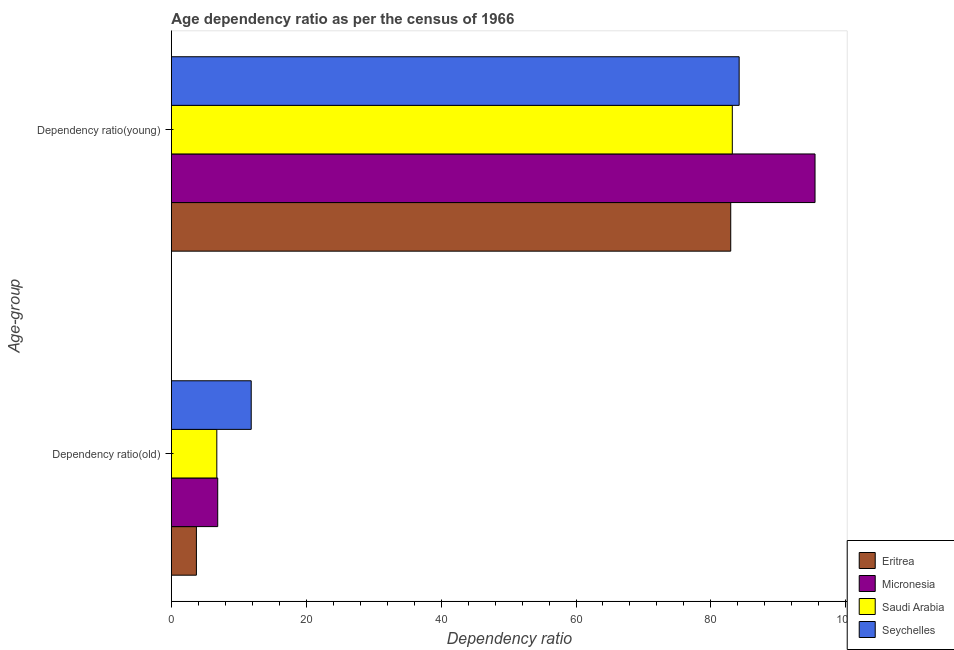How many groups of bars are there?
Make the answer very short. 2. Are the number of bars on each tick of the Y-axis equal?
Keep it short and to the point. Yes. How many bars are there on the 1st tick from the bottom?
Offer a very short reply. 4. What is the label of the 1st group of bars from the top?
Provide a succinct answer. Dependency ratio(young). What is the age dependency ratio(young) in Saudi Arabia?
Your response must be concise. 83.18. Across all countries, what is the maximum age dependency ratio(old)?
Provide a succinct answer. 11.84. Across all countries, what is the minimum age dependency ratio(young)?
Provide a short and direct response. 82.95. In which country was the age dependency ratio(old) maximum?
Keep it short and to the point. Seychelles. In which country was the age dependency ratio(young) minimum?
Make the answer very short. Eritrea. What is the total age dependency ratio(old) in the graph?
Make the answer very short. 29.16. What is the difference between the age dependency ratio(old) in Eritrea and that in Seychelles?
Offer a very short reply. -8.13. What is the difference between the age dependency ratio(old) in Eritrea and the age dependency ratio(young) in Seychelles?
Keep it short and to the point. -80.48. What is the average age dependency ratio(old) per country?
Provide a succinct answer. 7.29. What is the difference between the age dependency ratio(young) and age dependency ratio(old) in Micronesia?
Your answer should be compact. 88.57. What is the ratio of the age dependency ratio(old) in Micronesia to that in Eritrea?
Provide a succinct answer. 1.85. What does the 4th bar from the top in Dependency ratio(old) represents?
Ensure brevity in your answer.  Eritrea. What does the 4th bar from the bottom in Dependency ratio(young) represents?
Ensure brevity in your answer.  Seychelles. How many bars are there?
Provide a short and direct response. 8. Are all the bars in the graph horizontal?
Offer a very short reply. Yes. Are the values on the major ticks of X-axis written in scientific E-notation?
Keep it short and to the point. No. Does the graph contain any zero values?
Provide a succinct answer. No. Does the graph contain grids?
Provide a short and direct response. No. Where does the legend appear in the graph?
Offer a very short reply. Bottom right. What is the title of the graph?
Make the answer very short. Age dependency ratio as per the census of 1966. What is the label or title of the X-axis?
Keep it short and to the point. Dependency ratio. What is the label or title of the Y-axis?
Give a very brief answer. Age-group. What is the Dependency ratio in Eritrea in Dependency ratio(old)?
Provide a short and direct response. 3.71. What is the Dependency ratio of Micronesia in Dependency ratio(old)?
Provide a succinct answer. 6.87. What is the Dependency ratio in Saudi Arabia in Dependency ratio(old)?
Your response must be concise. 6.74. What is the Dependency ratio in Seychelles in Dependency ratio(old)?
Offer a very short reply. 11.84. What is the Dependency ratio of Eritrea in Dependency ratio(young)?
Your response must be concise. 82.95. What is the Dependency ratio in Micronesia in Dependency ratio(young)?
Provide a succinct answer. 95.45. What is the Dependency ratio in Saudi Arabia in Dependency ratio(young)?
Give a very brief answer. 83.18. What is the Dependency ratio of Seychelles in Dependency ratio(young)?
Your answer should be very brief. 84.2. Across all Age-group, what is the maximum Dependency ratio of Eritrea?
Your answer should be compact. 82.95. Across all Age-group, what is the maximum Dependency ratio of Micronesia?
Provide a succinct answer. 95.45. Across all Age-group, what is the maximum Dependency ratio in Saudi Arabia?
Your response must be concise. 83.18. Across all Age-group, what is the maximum Dependency ratio in Seychelles?
Ensure brevity in your answer.  84.2. Across all Age-group, what is the minimum Dependency ratio of Eritrea?
Your answer should be compact. 3.71. Across all Age-group, what is the minimum Dependency ratio of Micronesia?
Make the answer very short. 6.87. Across all Age-group, what is the minimum Dependency ratio of Saudi Arabia?
Provide a succinct answer. 6.74. Across all Age-group, what is the minimum Dependency ratio of Seychelles?
Ensure brevity in your answer.  11.84. What is the total Dependency ratio of Eritrea in the graph?
Your response must be concise. 86.66. What is the total Dependency ratio of Micronesia in the graph?
Ensure brevity in your answer.  102.32. What is the total Dependency ratio in Saudi Arabia in the graph?
Keep it short and to the point. 89.92. What is the total Dependency ratio in Seychelles in the graph?
Your answer should be very brief. 96.03. What is the difference between the Dependency ratio in Eritrea in Dependency ratio(old) and that in Dependency ratio(young)?
Offer a terse response. -79.23. What is the difference between the Dependency ratio in Micronesia in Dependency ratio(old) and that in Dependency ratio(young)?
Provide a short and direct response. -88.57. What is the difference between the Dependency ratio of Saudi Arabia in Dependency ratio(old) and that in Dependency ratio(young)?
Provide a short and direct response. -76.44. What is the difference between the Dependency ratio in Seychelles in Dependency ratio(old) and that in Dependency ratio(young)?
Make the answer very short. -72.36. What is the difference between the Dependency ratio of Eritrea in Dependency ratio(old) and the Dependency ratio of Micronesia in Dependency ratio(young)?
Offer a terse response. -91.73. What is the difference between the Dependency ratio of Eritrea in Dependency ratio(old) and the Dependency ratio of Saudi Arabia in Dependency ratio(young)?
Offer a very short reply. -79.47. What is the difference between the Dependency ratio in Eritrea in Dependency ratio(old) and the Dependency ratio in Seychelles in Dependency ratio(young)?
Your response must be concise. -80.48. What is the difference between the Dependency ratio in Micronesia in Dependency ratio(old) and the Dependency ratio in Saudi Arabia in Dependency ratio(young)?
Your answer should be very brief. -76.31. What is the difference between the Dependency ratio in Micronesia in Dependency ratio(old) and the Dependency ratio in Seychelles in Dependency ratio(young)?
Offer a very short reply. -77.32. What is the difference between the Dependency ratio in Saudi Arabia in Dependency ratio(old) and the Dependency ratio in Seychelles in Dependency ratio(young)?
Your answer should be very brief. -77.46. What is the average Dependency ratio in Eritrea per Age-group?
Keep it short and to the point. 43.33. What is the average Dependency ratio in Micronesia per Age-group?
Provide a short and direct response. 51.16. What is the average Dependency ratio of Saudi Arabia per Age-group?
Keep it short and to the point. 44.96. What is the average Dependency ratio in Seychelles per Age-group?
Ensure brevity in your answer.  48.02. What is the difference between the Dependency ratio in Eritrea and Dependency ratio in Micronesia in Dependency ratio(old)?
Make the answer very short. -3.16. What is the difference between the Dependency ratio in Eritrea and Dependency ratio in Saudi Arabia in Dependency ratio(old)?
Offer a terse response. -3.03. What is the difference between the Dependency ratio in Eritrea and Dependency ratio in Seychelles in Dependency ratio(old)?
Provide a succinct answer. -8.13. What is the difference between the Dependency ratio in Micronesia and Dependency ratio in Saudi Arabia in Dependency ratio(old)?
Your response must be concise. 0.13. What is the difference between the Dependency ratio of Micronesia and Dependency ratio of Seychelles in Dependency ratio(old)?
Make the answer very short. -4.97. What is the difference between the Dependency ratio of Saudi Arabia and Dependency ratio of Seychelles in Dependency ratio(old)?
Provide a succinct answer. -5.1. What is the difference between the Dependency ratio of Eritrea and Dependency ratio of Micronesia in Dependency ratio(young)?
Offer a terse response. -12.5. What is the difference between the Dependency ratio in Eritrea and Dependency ratio in Saudi Arabia in Dependency ratio(young)?
Your answer should be very brief. -0.23. What is the difference between the Dependency ratio of Eritrea and Dependency ratio of Seychelles in Dependency ratio(young)?
Offer a terse response. -1.25. What is the difference between the Dependency ratio of Micronesia and Dependency ratio of Saudi Arabia in Dependency ratio(young)?
Offer a terse response. 12.27. What is the difference between the Dependency ratio of Micronesia and Dependency ratio of Seychelles in Dependency ratio(young)?
Your answer should be compact. 11.25. What is the difference between the Dependency ratio in Saudi Arabia and Dependency ratio in Seychelles in Dependency ratio(young)?
Offer a very short reply. -1.02. What is the ratio of the Dependency ratio in Eritrea in Dependency ratio(old) to that in Dependency ratio(young)?
Keep it short and to the point. 0.04. What is the ratio of the Dependency ratio of Micronesia in Dependency ratio(old) to that in Dependency ratio(young)?
Offer a very short reply. 0.07. What is the ratio of the Dependency ratio in Saudi Arabia in Dependency ratio(old) to that in Dependency ratio(young)?
Your answer should be very brief. 0.08. What is the ratio of the Dependency ratio in Seychelles in Dependency ratio(old) to that in Dependency ratio(young)?
Keep it short and to the point. 0.14. What is the difference between the highest and the second highest Dependency ratio of Eritrea?
Provide a short and direct response. 79.23. What is the difference between the highest and the second highest Dependency ratio in Micronesia?
Your answer should be very brief. 88.57. What is the difference between the highest and the second highest Dependency ratio of Saudi Arabia?
Ensure brevity in your answer.  76.44. What is the difference between the highest and the second highest Dependency ratio in Seychelles?
Your answer should be compact. 72.36. What is the difference between the highest and the lowest Dependency ratio of Eritrea?
Ensure brevity in your answer.  79.23. What is the difference between the highest and the lowest Dependency ratio of Micronesia?
Provide a short and direct response. 88.57. What is the difference between the highest and the lowest Dependency ratio of Saudi Arabia?
Your answer should be compact. 76.44. What is the difference between the highest and the lowest Dependency ratio in Seychelles?
Provide a short and direct response. 72.36. 